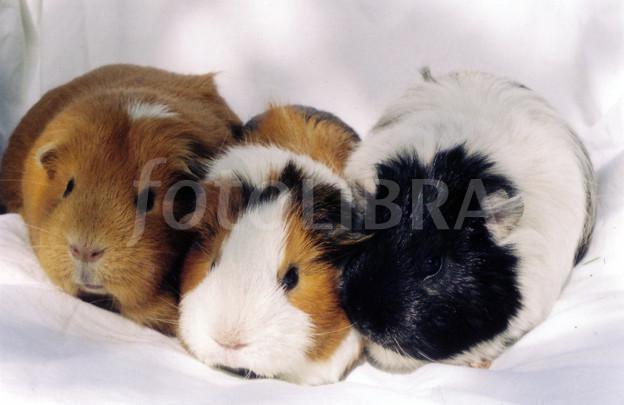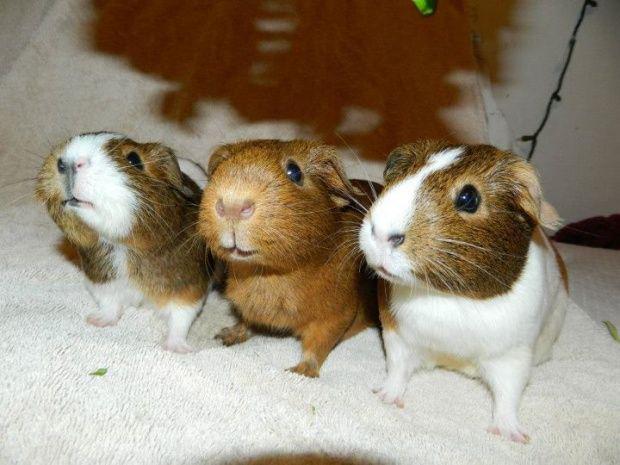The first image is the image on the left, the second image is the image on the right. Examine the images to the left and right. Is the description "In the right image, the animals have something covering their heads." accurate? Answer yes or no. No. 